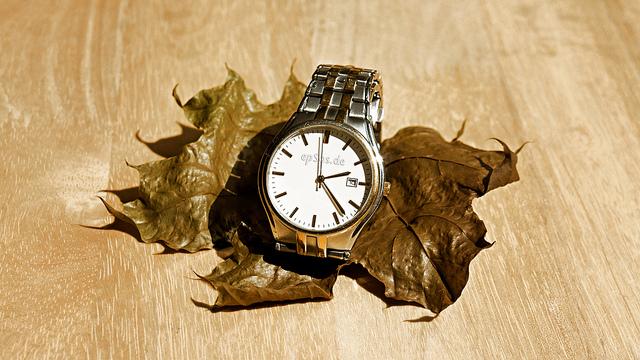What is the watch sitting on?
Answer briefly. Leaf. What is the surface made of?
Answer briefly. Wood. What time is it?
Quick response, please. 2:23. 